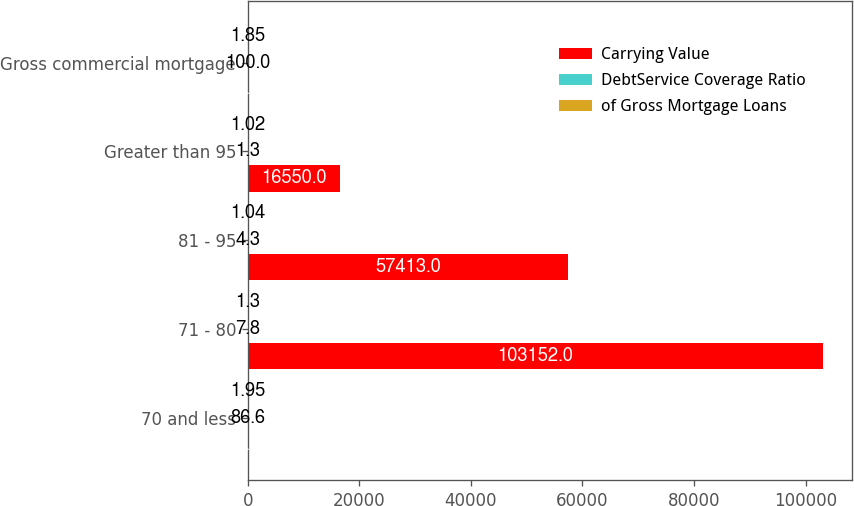Convert chart. <chart><loc_0><loc_0><loc_500><loc_500><stacked_bar_chart><ecel><fcel>70 and less<fcel>71 - 80<fcel>81 - 95<fcel>Greater than 95<fcel>Gross commercial mortgage<nl><fcel>Carrying Value<fcel>4.3<fcel>103152<fcel>57413<fcel>16550<fcel>4.3<nl><fcel>DebtService Coverage Ratio<fcel>86.6<fcel>7.8<fcel>4.3<fcel>1.3<fcel>100<nl><fcel>of Gross Mortgage Loans<fcel>1.95<fcel>1.3<fcel>1.04<fcel>1.02<fcel>1.85<nl></chart> 